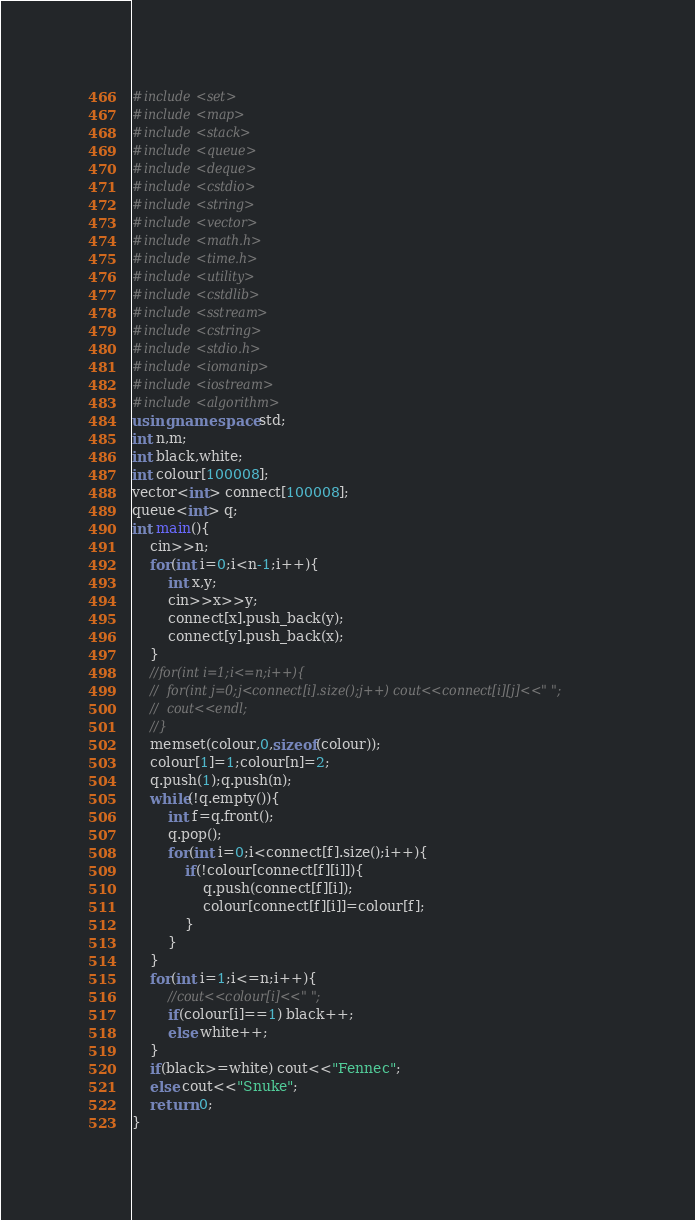<code> <loc_0><loc_0><loc_500><loc_500><_C++_>#include<set>
#include<map>
#include<stack>
#include<queue>
#include<deque>
#include<cstdio>
#include<string>
#include<vector>
#include<math.h>
#include<time.h>
#include<utility>
#include<cstdlib>
#include<sstream>
#include<cstring>
#include<stdio.h>
#include<iomanip>
#include<iostream>
#include<algorithm>
using namespace std;
int n,m;
int black,white; 
int colour[100008];
vector<int> connect[100008];
queue<int> q;
int main(){
	cin>>n;
	for(int i=0;i<n-1;i++){
		int x,y;
		cin>>x>>y;
		connect[x].push_back(y);
		connect[y].push_back(x);
	}
	//for(int i=1;i<=n;i++){
	//	for(int j=0;j<connect[i].size();j++) cout<<connect[i][j]<<" ";
	//	cout<<endl;
	//}
	memset(colour,0,sizeof(colour));
	colour[1]=1;colour[n]=2;
	q.push(1);q.push(n);
	while(!q.empty()){
		int f=q.front();
		q.pop();
		for(int i=0;i<connect[f].size();i++){
			if(!colour[connect[f][i]]){
				q.push(connect[f][i]);
				colour[connect[f][i]]=colour[f];
			}
		}
	}
	for(int i=1;i<=n;i++){
		//cout<<colour[i]<<" ";
		if(colour[i]==1) black++;
	    else white++;
	}
	if(black>=white) cout<<"Fennec";
	else cout<<"Snuke";
	return 0;
} </code> 